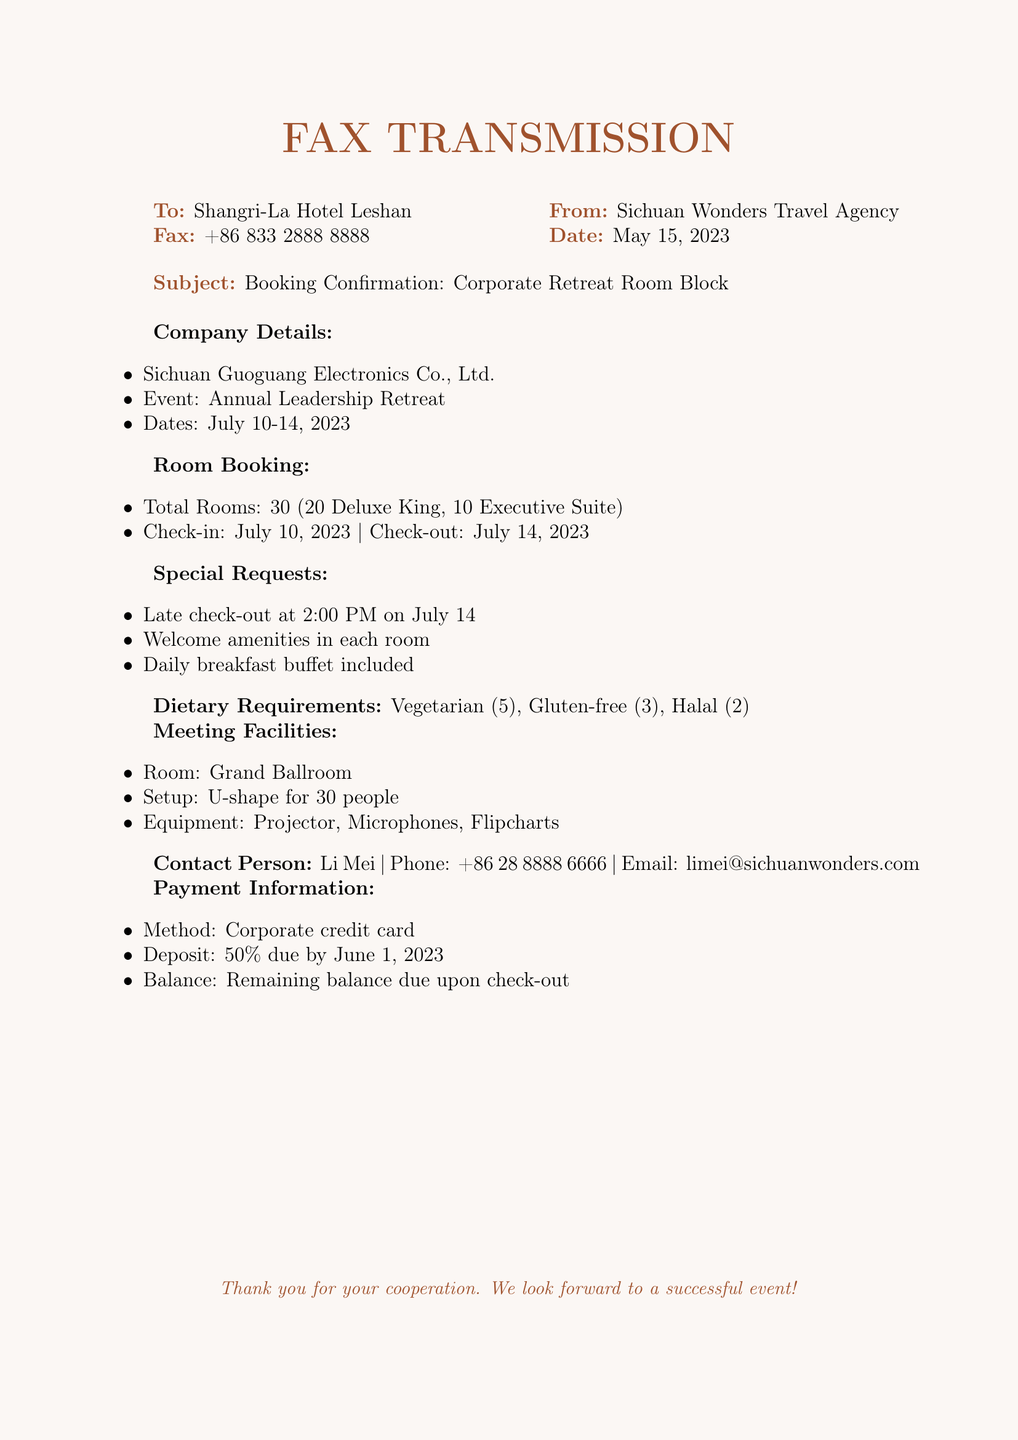What is the name of the company? The document specifies the name of the company organizing the retreat as Sichuan Guoguang Electronics Co., Ltd.
Answer: Sichuan Guoguang Electronics Co., Ltd What are the total number of Deluxe King rooms booked? The document states that 20 Deluxe King rooms are included in the booking.
Answer: 20 What is the check-in date for the booking? The check-in date indicated in the document is July 10, 2023.
Answer: July 10, 2023 How many gluten-free meals are required? The dietary requirements section specifies that 3 gluten-free meals are needed.
Answer: 3 What type of setup is requested for the Grand Ballroom? The document states that a U-shape setup is requested for the Grand Ballroom meeting.
Answer: U-shape What is the payment method mentioned in the document? The document specifies that the method of payment is a corporate credit card.
Answer: Corporate credit card What is the late check-out time requested? The document indicates the requested late check-out time is 2:00 PM on July 14.
Answer: 2:00 PM Who is the contact person for the booking? The document identifies Li Mei as the contact person for this booking.
Answer: Li Mei When is the deposit due? According to the document, the deposit is due by June 1, 2023.
Answer: June 1, 2023 